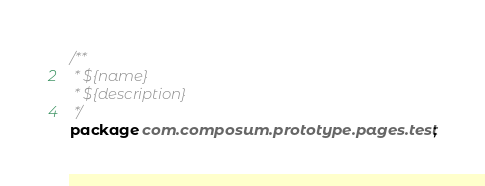<code> <loc_0><loc_0><loc_500><loc_500><_Java_>/**
 * ${name}
 * ${description}
 */
package com.composum.prototype.pages.test;
</code> 